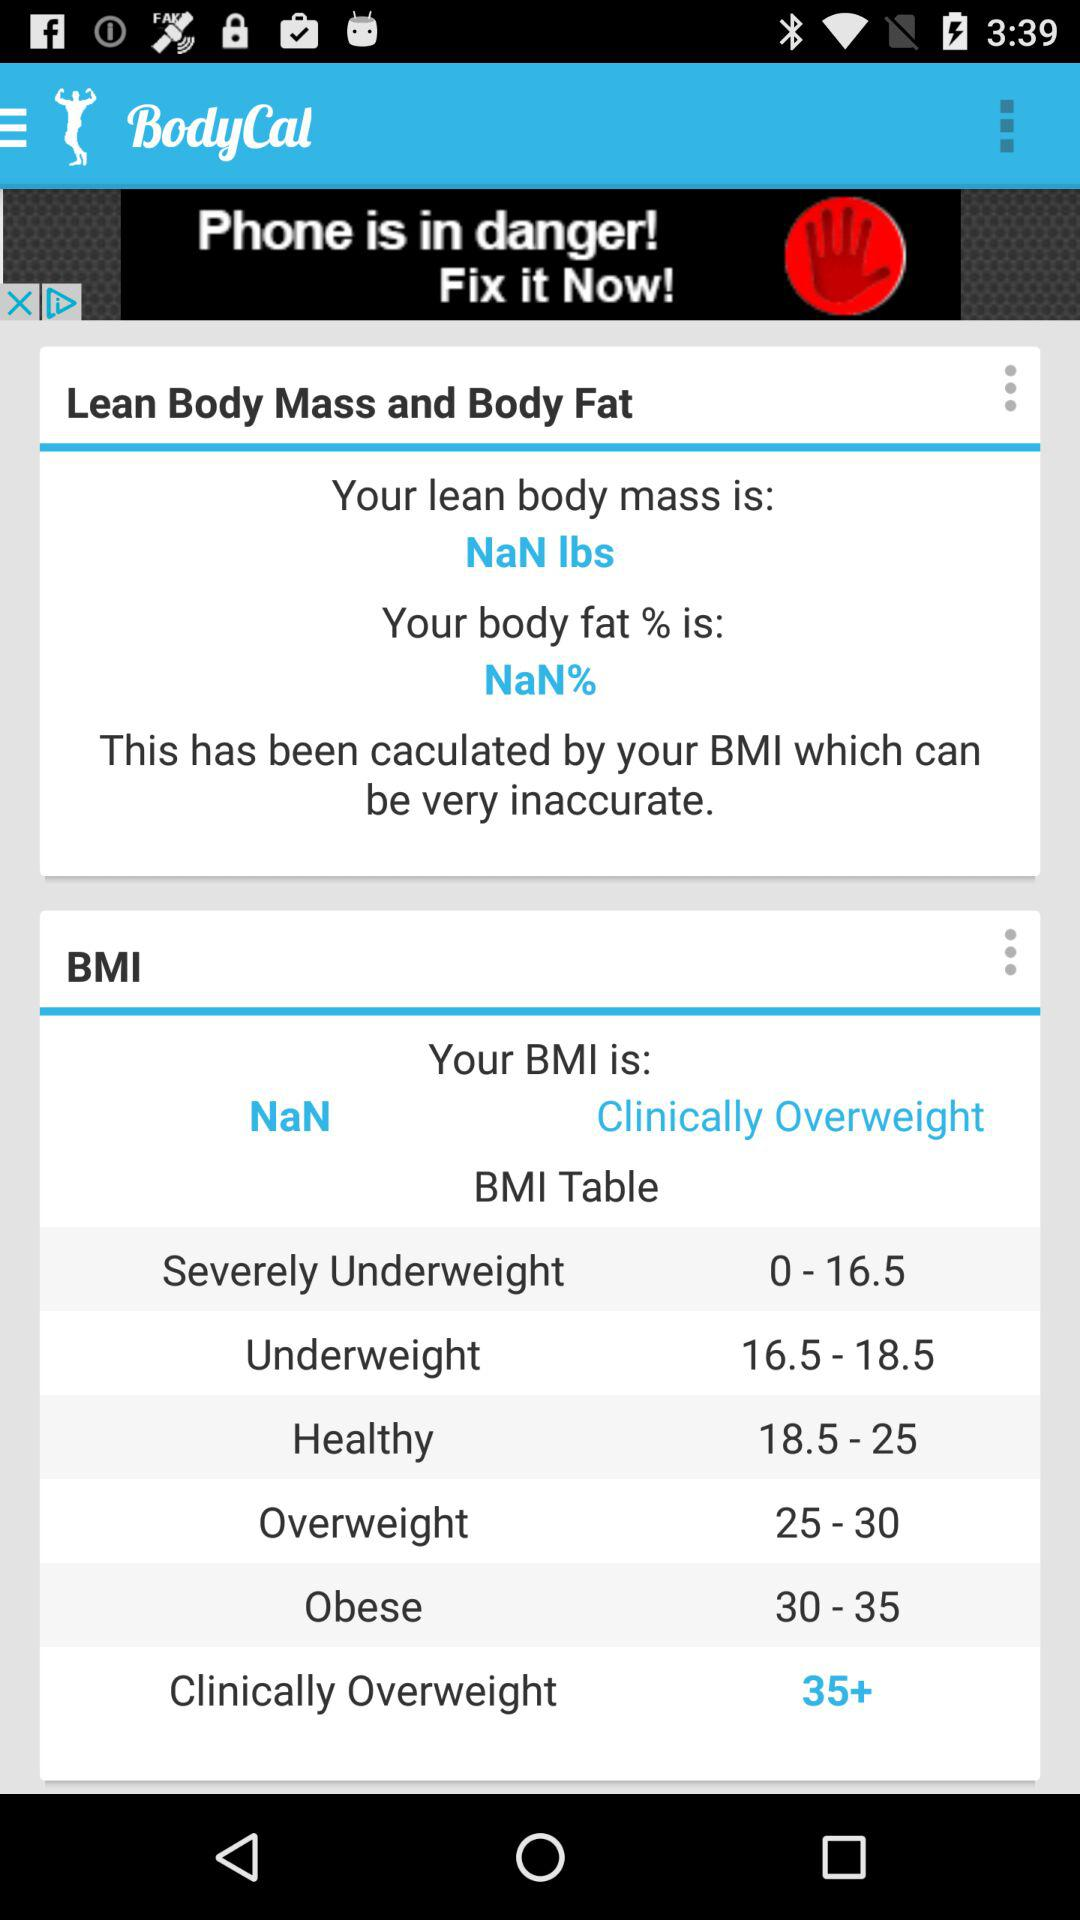What is the name of the application? The name of the application is "BodyCal". 